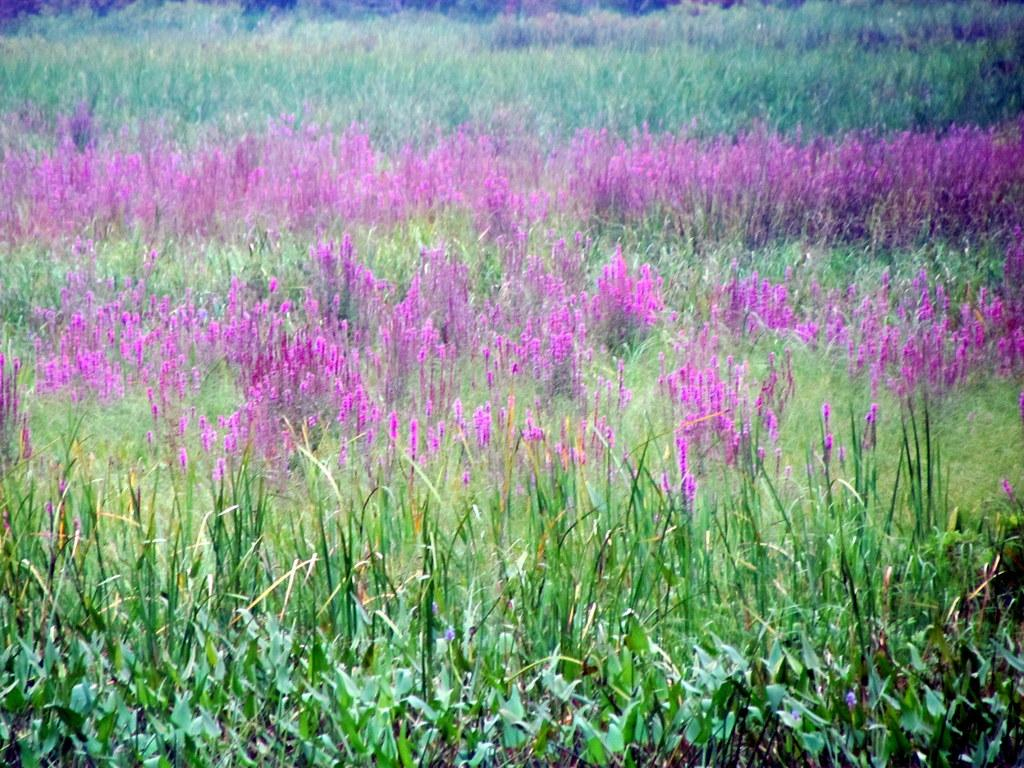What type of living organisms can be seen in the image? The image contains plants. Can you describe the plants in the middle of the image? There are plants in pink color in the middle of the image. What color are the leaves at the bottom of the image? There are green leaves at the bottom of the image. What type of toothpaste is being used to clean the ship in the image? There is no toothpaste or ship present in the image; it features plants with pink color and green leaves. 